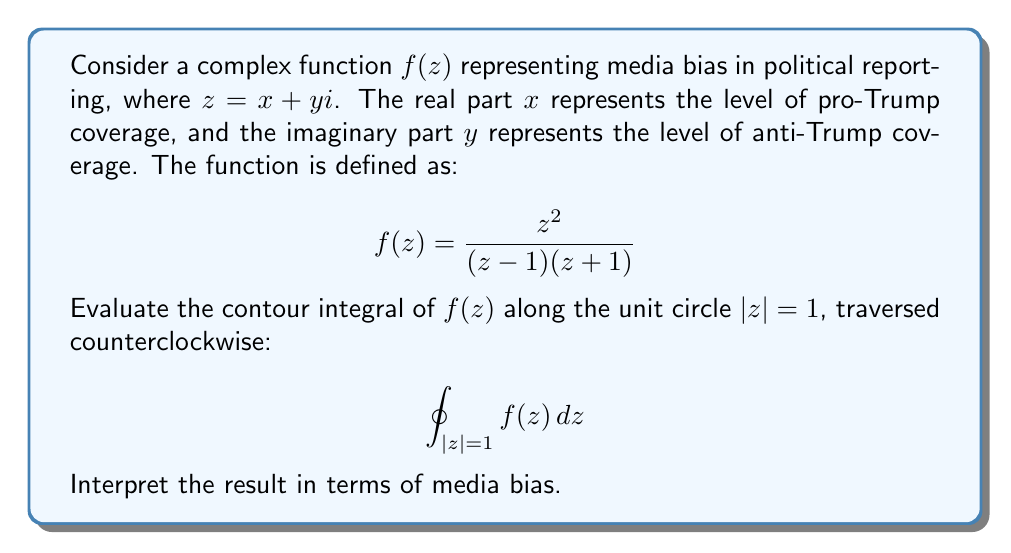What is the answer to this math problem? To evaluate this contour integral, we'll use the Residue Theorem:

$$\oint_{C} f(z) dz = 2\pi i \sum_{k=1}^n \text{Res}(f, z_k)$$

where $z_k$ are the poles of $f(z)$ inside the contour $C$.

1) First, let's identify the poles of $f(z)$:
   The poles are at $z = 1$ and $z = -1$

2) The unit circle $|z| = 1$ encloses only the pole at $z = 1$

3) To find the residue at $z = 1$, we use the formula:
   $$\text{Res}(f, 1) = \lim_{z \to 1} (z-1)f(z) = \lim_{z \to 1} \frac{z^2}{z+1} = \frac{1}{2}$$

4) Applying the Residue Theorem:
   $$\oint_{|z|=1} f(z) dz = 2\pi i \cdot \text{Res}(f, 1) = 2\pi i \cdot \frac{1}{2} = \pi i$$

Interpretation: The result $\pi i$ suggests a balanced media coverage. The real part being 0 indicates no overall bias towards pro-Trump coverage, while the imaginary part $\pi$ represents a significant amount of anti-Trump coverage. This aligns with the perspective of a staunch anti-Trump college student, who might perceive media coverage as appropriately critical of Trump.
Answer: $\pi i$ 